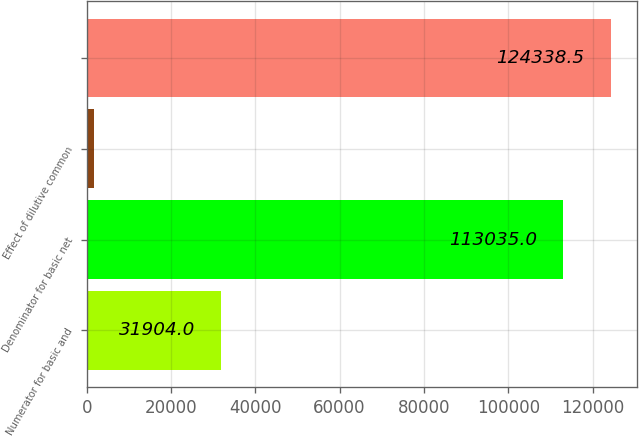Convert chart to OTSL. <chart><loc_0><loc_0><loc_500><loc_500><bar_chart><fcel>Numerator for basic and<fcel>Denominator for basic net<fcel>Effect of dilutive common<fcel>Unnamed: 3<nl><fcel>31904<fcel>113035<fcel>1740<fcel>124338<nl></chart> 